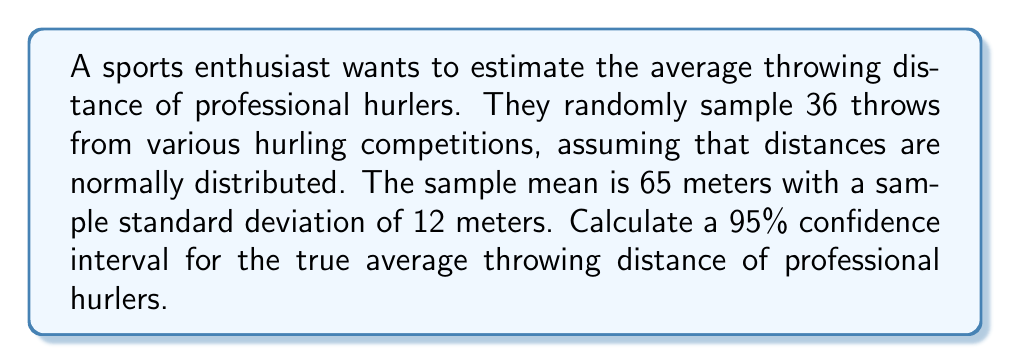Can you answer this question? Let's approach this step-by-step:

1) We're dealing with a confidence interval for a population mean with unknown population standard deviation. We'll use the t-distribution.

2) Given information:
   - Sample size: $n = 36$
   - Sample mean: $\bar{x} = 65$ meters
   - Sample standard deviation: $s = 12$ meters
   - Confidence level: 95%

3) The formula for the confidence interval is:

   $$\bar{x} \pm t_{\alpha/2, n-1} \cdot \frac{s}{\sqrt{n}}$$

4) We need to find $t_{\alpha/2, n-1}$:
   - $\alpha = 1 - 0.95 = 0.05$
   - Degrees of freedom: $df = n - 1 = 35$
   - Using a t-table or calculator, we find $t_{0.025, 35} \approx 2.030$

5) Now, let's calculate the margin of error:

   $$\text{Margin of Error} = t_{\alpha/2, n-1} \cdot \frac{s}{\sqrt{n}} = 2.030 \cdot \frac{12}{\sqrt{36}} \approx 4.06$$

6) Finally, we can calculate the confidence interval:

   $$65 \pm 4.06$$

   Lower bound: $65 - 4.06 = 60.94$
   Upper bound: $65 + 4.06 = 69.06$

Therefore, we are 95% confident that the true average throwing distance of professional hurlers is between 60.94 and 69.06 meters.
Answer: (60.94, 69.06) meters 